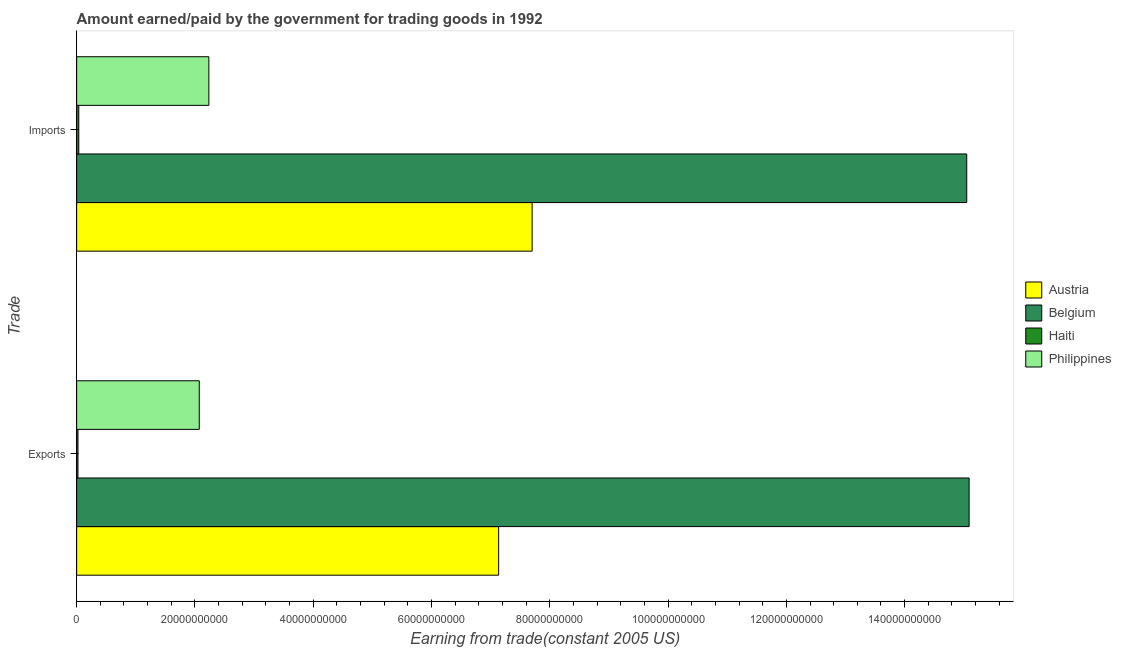Are the number of bars per tick equal to the number of legend labels?
Ensure brevity in your answer.  Yes. Are the number of bars on each tick of the Y-axis equal?
Ensure brevity in your answer.  Yes. What is the label of the 2nd group of bars from the top?
Your response must be concise. Exports. What is the amount paid for imports in Philippines?
Ensure brevity in your answer.  2.24e+1. Across all countries, what is the maximum amount earned from exports?
Keep it short and to the point. 1.51e+11. Across all countries, what is the minimum amount earned from exports?
Give a very brief answer. 2.21e+08. In which country was the amount earned from exports minimum?
Your answer should be compact. Haiti. What is the total amount paid for imports in the graph?
Ensure brevity in your answer.  2.50e+11. What is the difference between the amount paid for imports in Philippines and that in Austria?
Your response must be concise. -5.47e+1. What is the difference between the amount paid for imports in Philippines and the amount earned from exports in Austria?
Give a very brief answer. -4.90e+1. What is the average amount earned from exports per country?
Make the answer very short. 6.08e+1. What is the difference between the amount earned from exports and amount paid for imports in Belgium?
Offer a terse response. 4.04e+08. What is the ratio of the amount earned from exports in Philippines to that in Belgium?
Keep it short and to the point. 0.14. In how many countries, is the amount paid for imports greater than the average amount paid for imports taken over all countries?
Offer a very short reply. 2. What does the 1st bar from the top in Imports represents?
Keep it short and to the point. Philippines. How many bars are there?
Your answer should be compact. 8. Are all the bars in the graph horizontal?
Ensure brevity in your answer.  Yes. Are the values on the major ticks of X-axis written in scientific E-notation?
Your response must be concise. No. Does the graph contain grids?
Ensure brevity in your answer.  No. How many legend labels are there?
Your response must be concise. 4. How are the legend labels stacked?
Your response must be concise. Vertical. What is the title of the graph?
Ensure brevity in your answer.  Amount earned/paid by the government for trading goods in 1992. Does "Sweden" appear as one of the legend labels in the graph?
Your answer should be very brief. No. What is the label or title of the X-axis?
Provide a succinct answer. Earning from trade(constant 2005 US). What is the label or title of the Y-axis?
Ensure brevity in your answer.  Trade. What is the Earning from trade(constant 2005 US) of Austria in Exports?
Provide a short and direct response. 7.14e+1. What is the Earning from trade(constant 2005 US) of Belgium in Exports?
Give a very brief answer. 1.51e+11. What is the Earning from trade(constant 2005 US) of Haiti in Exports?
Provide a succinct answer. 2.21e+08. What is the Earning from trade(constant 2005 US) in Philippines in Exports?
Provide a succinct answer. 2.07e+1. What is the Earning from trade(constant 2005 US) in Austria in Imports?
Your response must be concise. 7.70e+1. What is the Earning from trade(constant 2005 US) of Belgium in Imports?
Keep it short and to the point. 1.51e+11. What is the Earning from trade(constant 2005 US) of Haiti in Imports?
Provide a short and direct response. 3.58e+08. What is the Earning from trade(constant 2005 US) of Philippines in Imports?
Your response must be concise. 2.24e+1. Across all Trade, what is the maximum Earning from trade(constant 2005 US) in Austria?
Give a very brief answer. 7.70e+1. Across all Trade, what is the maximum Earning from trade(constant 2005 US) of Belgium?
Your response must be concise. 1.51e+11. Across all Trade, what is the maximum Earning from trade(constant 2005 US) of Haiti?
Provide a short and direct response. 3.58e+08. Across all Trade, what is the maximum Earning from trade(constant 2005 US) of Philippines?
Provide a short and direct response. 2.24e+1. Across all Trade, what is the minimum Earning from trade(constant 2005 US) in Austria?
Your answer should be compact. 7.14e+1. Across all Trade, what is the minimum Earning from trade(constant 2005 US) of Belgium?
Your answer should be very brief. 1.51e+11. Across all Trade, what is the minimum Earning from trade(constant 2005 US) in Haiti?
Offer a very short reply. 2.21e+08. Across all Trade, what is the minimum Earning from trade(constant 2005 US) of Philippines?
Provide a short and direct response. 2.07e+1. What is the total Earning from trade(constant 2005 US) of Austria in the graph?
Provide a succinct answer. 1.48e+11. What is the total Earning from trade(constant 2005 US) in Belgium in the graph?
Make the answer very short. 3.01e+11. What is the total Earning from trade(constant 2005 US) in Haiti in the graph?
Make the answer very short. 5.78e+08. What is the total Earning from trade(constant 2005 US) of Philippines in the graph?
Provide a short and direct response. 4.31e+1. What is the difference between the Earning from trade(constant 2005 US) of Austria in Exports and that in Imports?
Keep it short and to the point. -5.66e+09. What is the difference between the Earning from trade(constant 2005 US) of Belgium in Exports and that in Imports?
Ensure brevity in your answer.  4.04e+08. What is the difference between the Earning from trade(constant 2005 US) in Haiti in Exports and that in Imports?
Ensure brevity in your answer.  -1.37e+08. What is the difference between the Earning from trade(constant 2005 US) in Philippines in Exports and that in Imports?
Your answer should be very brief. -1.62e+09. What is the difference between the Earning from trade(constant 2005 US) in Austria in Exports and the Earning from trade(constant 2005 US) in Belgium in Imports?
Offer a very short reply. -7.91e+1. What is the difference between the Earning from trade(constant 2005 US) of Austria in Exports and the Earning from trade(constant 2005 US) of Haiti in Imports?
Make the answer very short. 7.10e+1. What is the difference between the Earning from trade(constant 2005 US) in Austria in Exports and the Earning from trade(constant 2005 US) in Philippines in Imports?
Keep it short and to the point. 4.90e+1. What is the difference between the Earning from trade(constant 2005 US) of Belgium in Exports and the Earning from trade(constant 2005 US) of Haiti in Imports?
Provide a short and direct response. 1.51e+11. What is the difference between the Earning from trade(constant 2005 US) of Belgium in Exports and the Earning from trade(constant 2005 US) of Philippines in Imports?
Ensure brevity in your answer.  1.29e+11. What is the difference between the Earning from trade(constant 2005 US) of Haiti in Exports and the Earning from trade(constant 2005 US) of Philippines in Imports?
Your answer should be compact. -2.21e+1. What is the average Earning from trade(constant 2005 US) of Austria per Trade?
Your answer should be compact. 7.42e+1. What is the average Earning from trade(constant 2005 US) of Belgium per Trade?
Make the answer very short. 1.51e+11. What is the average Earning from trade(constant 2005 US) in Haiti per Trade?
Keep it short and to the point. 2.89e+08. What is the average Earning from trade(constant 2005 US) of Philippines per Trade?
Keep it short and to the point. 2.15e+1. What is the difference between the Earning from trade(constant 2005 US) in Austria and Earning from trade(constant 2005 US) in Belgium in Exports?
Make the answer very short. -7.96e+1. What is the difference between the Earning from trade(constant 2005 US) in Austria and Earning from trade(constant 2005 US) in Haiti in Exports?
Ensure brevity in your answer.  7.11e+1. What is the difference between the Earning from trade(constant 2005 US) of Austria and Earning from trade(constant 2005 US) of Philippines in Exports?
Your answer should be compact. 5.06e+1. What is the difference between the Earning from trade(constant 2005 US) in Belgium and Earning from trade(constant 2005 US) in Haiti in Exports?
Offer a terse response. 1.51e+11. What is the difference between the Earning from trade(constant 2005 US) in Belgium and Earning from trade(constant 2005 US) in Philippines in Exports?
Offer a terse response. 1.30e+11. What is the difference between the Earning from trade(constant 2005 US) of Haiti and Earning from trade(constant 2005 US) of Philippines in Exports?
Your response must be concise. -2.05e+1. What is the difference between the Earning from trade(constant 2005 US) in Austria and Earning from trade(constant 2005 US) in Belgium in Imports?
Provide a succinct answer. -7.35e+1. What is the difference between the Earning from trade(constant 2005 US) of Austria and Earning from trade(constant 2005 US) of Haiti in Imports?
Your answer should be very brief. 7.67e+1. What is the difference between the Earning from trade(constant 2005 US) in Austria and Earning from trade(constant 2005 US) in Philippines in Imports?
Keep it short and to the point. 5.47e+1. What is the difference between the Earning from trade(constant 2005 US) in Belgium and Earning from trade(constant 2005 US) in Haiti in Imports?
Provide a short and direct response. 1.50e+11. What is the difference between the Earning from trade(constant 2005 US) in Belgium and Earning from trade(constant 2005 US) in Philippines in Imports?
Keep it short and to the point. 1.28e+11. What is the difference between the Earning from trade(constant 2005 US) in Haiti and Earning from trade(constant 2005 US) in Philippines in Imports?
Offer a terse response. -2.20e+1. What is the ratio of the Earning from trade(constant 2005 US) of Austria in Exports to that in Imports?
Make the answer very short. 0.93. What is the ratio of the Earning from trade(constant 2005 US) in Haiti in Exports to that in Imports?
Provide a short and direct response. 0.62. What is the ratio of the Earning from trade(constant 2005 US) of Philippines in Exports to that in Imports?
Provide a succinct answer. 0.93. What is the difference between the highest and the second highest Earning from trade(constant 2005 US) in Austria?
Give a very brief answer. 5.66e+09. What is the difference between the highest and the second highest Earning from trade(constant 2005 US) in Belgium?
Provide a succinct answer. 4.04e+08. What is the difference between the highest and the second highest Earning from trade(constant 2005 US) in Haiti?
Your response must be concise. 1.37e+08. What is the difference between the highest and the second highest Earning from trade(constant 2005 US) in Philippines?
Make the answer very short. 1.62e+09. What is the difference between the highest and the lowest Earning from trade(constant 2005 US) of Austria?
Offer a very short reply. 5.66e+09. What is the difference between the highest and the lowest Earning from trade(constant 2005 US) in Belgium?
Keep it short and to the point. 4.04e+08. What is the difference between the highest and the lowest Earning from trade(constant 2005 US) in Haiti?
Ensure brevity in your answer.  1.37e+08. What is the difference between the highest and the lowest Earning from trade(constant 2005 US) of Philippines?
Make the answer very short. 1.62e+09. 